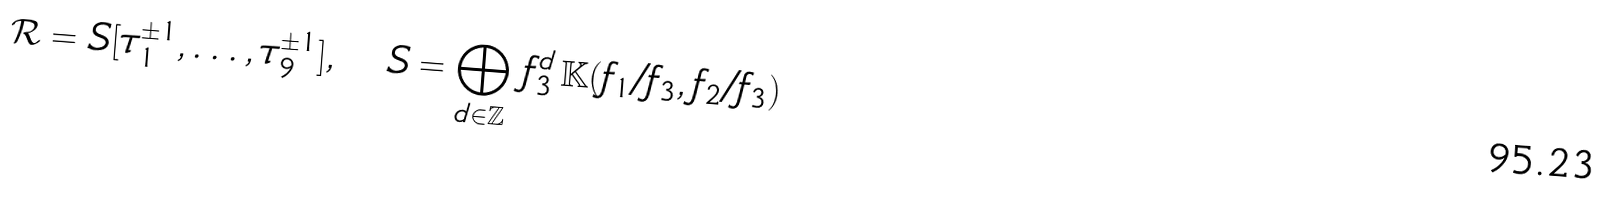<formula> <loc_0><loc_0><loc_500><loc_500>\mathcal { R } = S [ \tau _ { 1 } ^ { \pm 1 } , \dots , \tau _ { 9 } ^ { \pm 1 } ] , \quad S = \bigoplus _ { d \in \mathbb { Z } } \, f _ { 3 } ^ { d } \, \mathbb { K } ( f _ { 1 } / f _ { 3 } , f _ { 2 } / f _ { 3 } )</formula> 